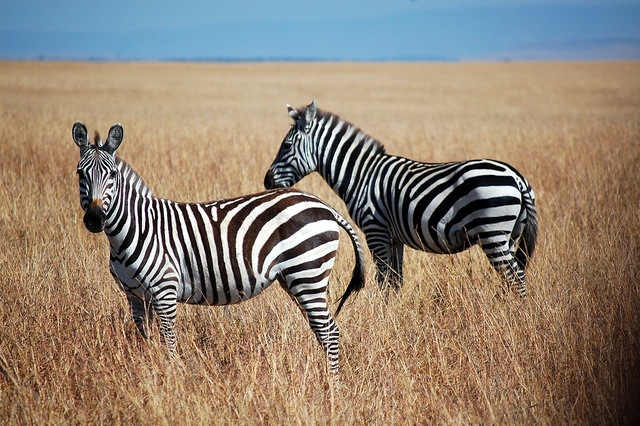Describe the objects in this image and their specific colors. I can see zebra in gray, black, white, and darkgray tones and zebra in gray, black, lightgray, and darkgray tones in this image. 